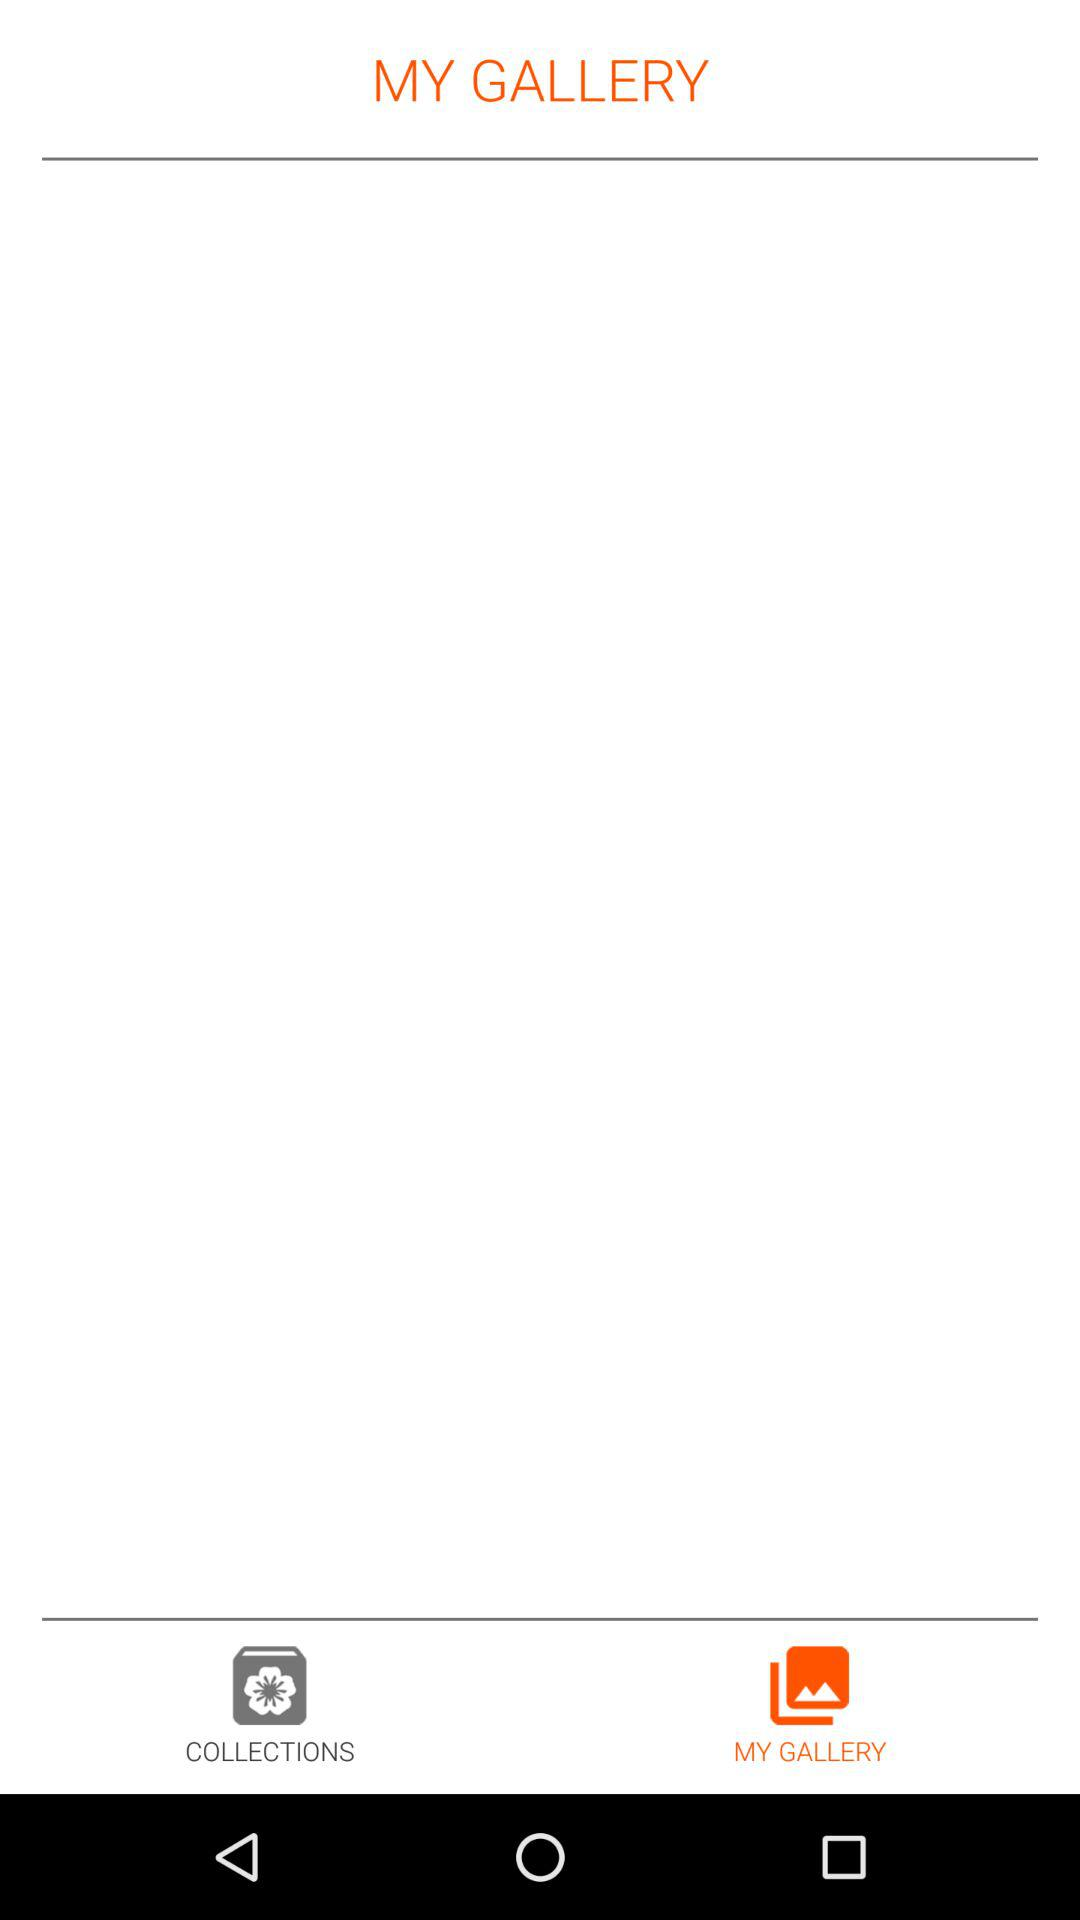How many images are in "MY GALLERY"?
When the provided information is insufficient, respond with <no answer>. <no answer> 